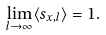<formula> <loc_0><loc_0><loc_500><loc_500>\lim _ { l \rightarrow \infty } \langle s _ { x , l } \rangle = 1 .</formula> 